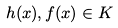<formula> <loc_0><loc_0><loc_500><loc_500>h ( x ) , f ( x ) \in K</formula> 